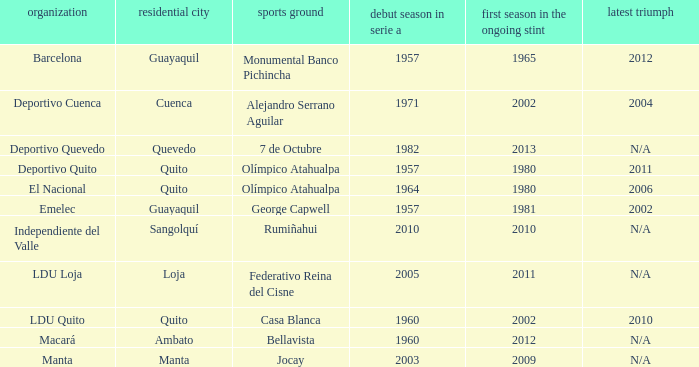Name the last title for cuenca 2004.0. 